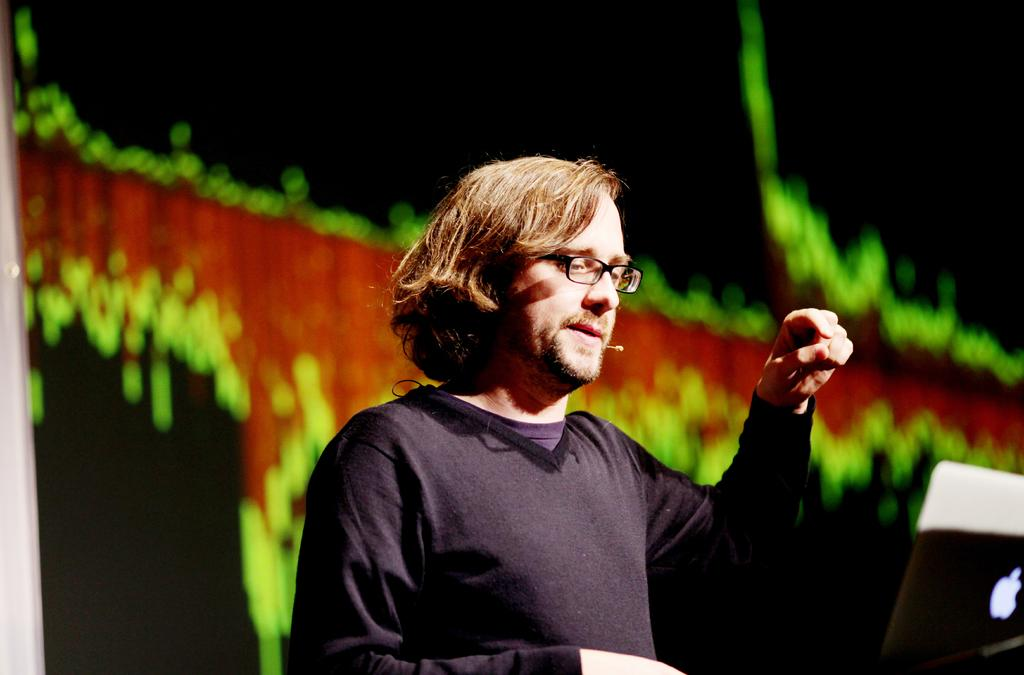What can be seen in the image? There is a person in the image. Can you describe the person's appearance? The person is wearing spectacles. What is the person holding in the image? The person is holding a mic. What object is in front of the person? There is a laptop in front of the person. What can be seen in the background of the image? There are colors visible in the background of the image. How many spiders are crawling on the person's spectacles in the image? There are no spiders visible on the person's spectacles in the image. 